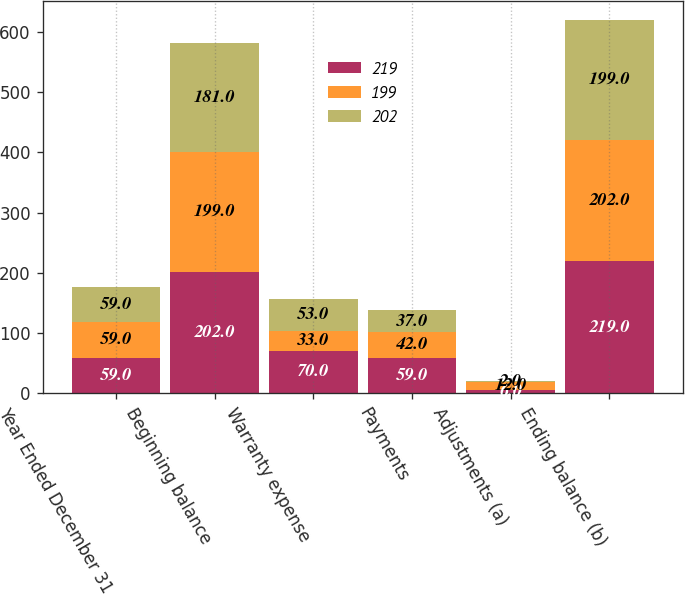Convert chart. <chart><loc_0><loc_0><loc_500><loc_500><stacked_bar_chart><ecel><fcel>Year Ended December 31<fcel>Beginning balance<fcel>Warranty expense<fcel>Payments<fcel>Adjustments (a)<fcel>Ending balance (b)<nl><fcel>219<fcel>59<fcel>202<fcel>70<fcel>59<fcel>6<fcel>219<nl><fcel>199<fcel>59<fcel>199<fcel>33<fcel>42<fcel>12<fcel>202<nl><fcel>202<fcel>59<fcel>181<fcel>53<fcel>37<fcel>2<fcel>199<nl></chart> 